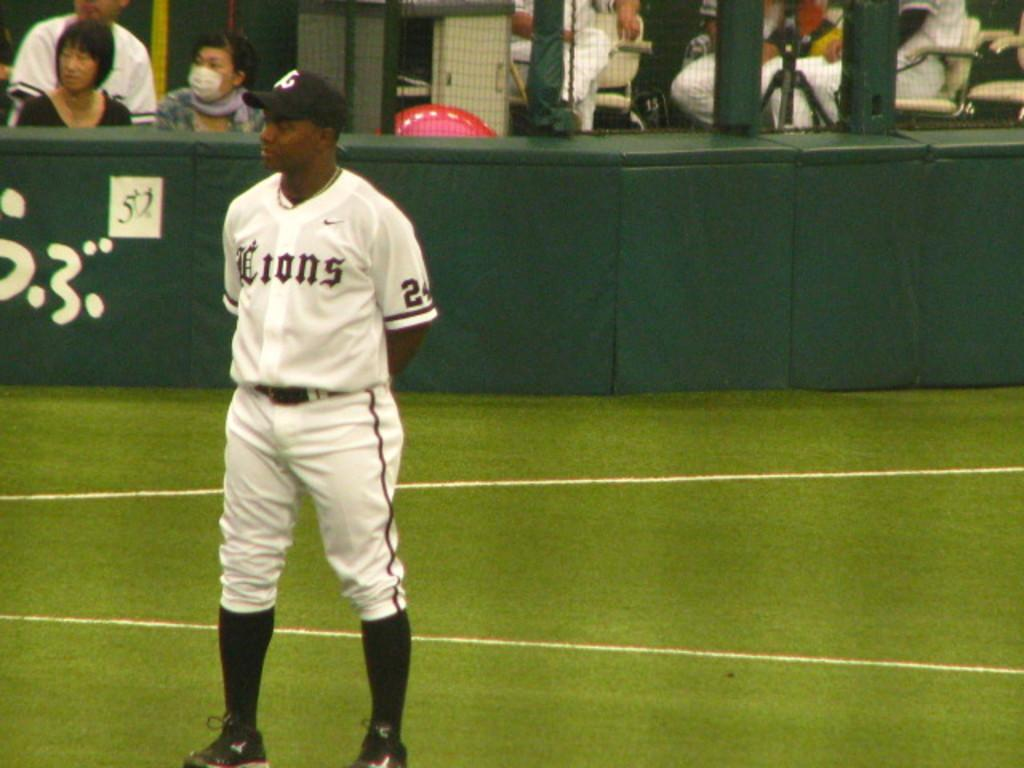<image>
Describe the image concisely. A baseball player who plays for the Lions stands on the field. 